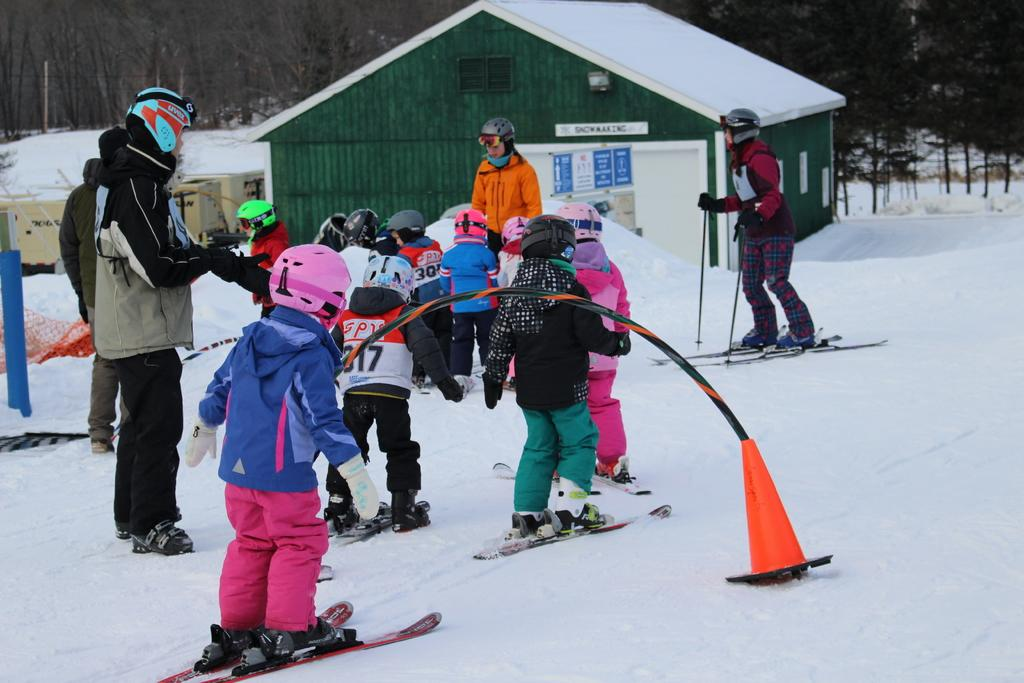What is happening in the image involving the group of kids? The kids are skating in the snow. Who is present in the image besides the kids? There are two persons on either side of the kids. What can be seen in the background of the image? There is a green building and trees in the background of the image. What type of disease is being treated by the band in the image? There is no band present in the image, and therefore no treatment of any disease can be observed. 